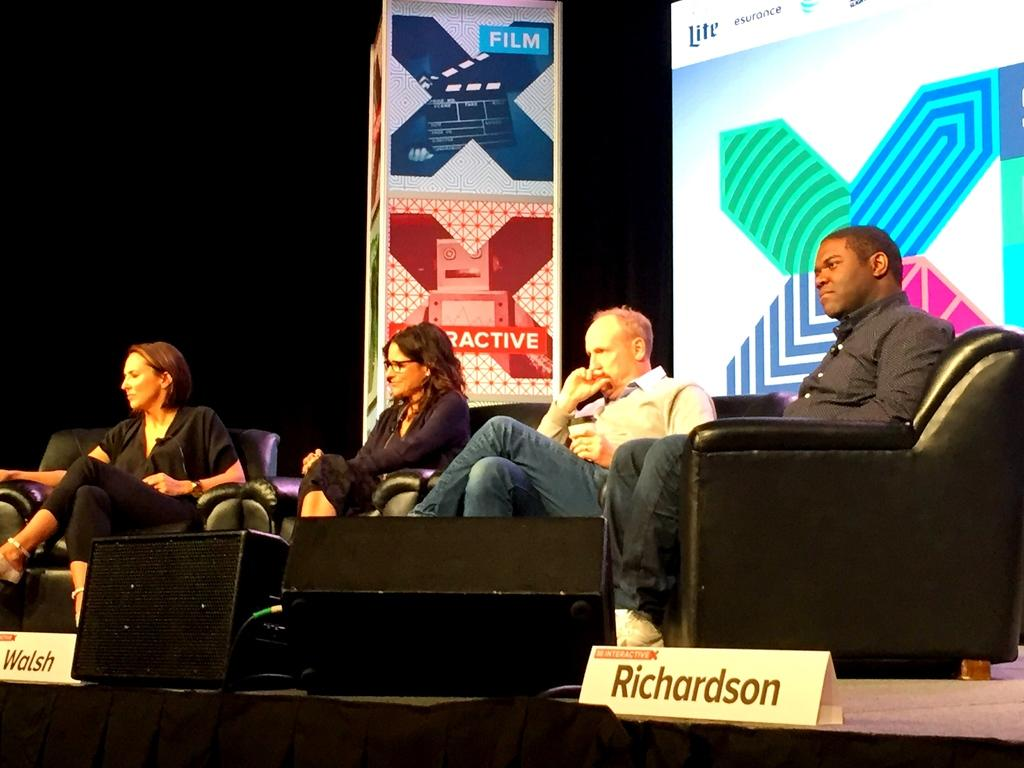Who or what can be seen in the image? There are people in the image. What are the people doing in the image? The people are sitting on chairs. What type of power can be seen in the image? There is no power source or electrical equipment visible in the image; it features people sitting on chairs. 